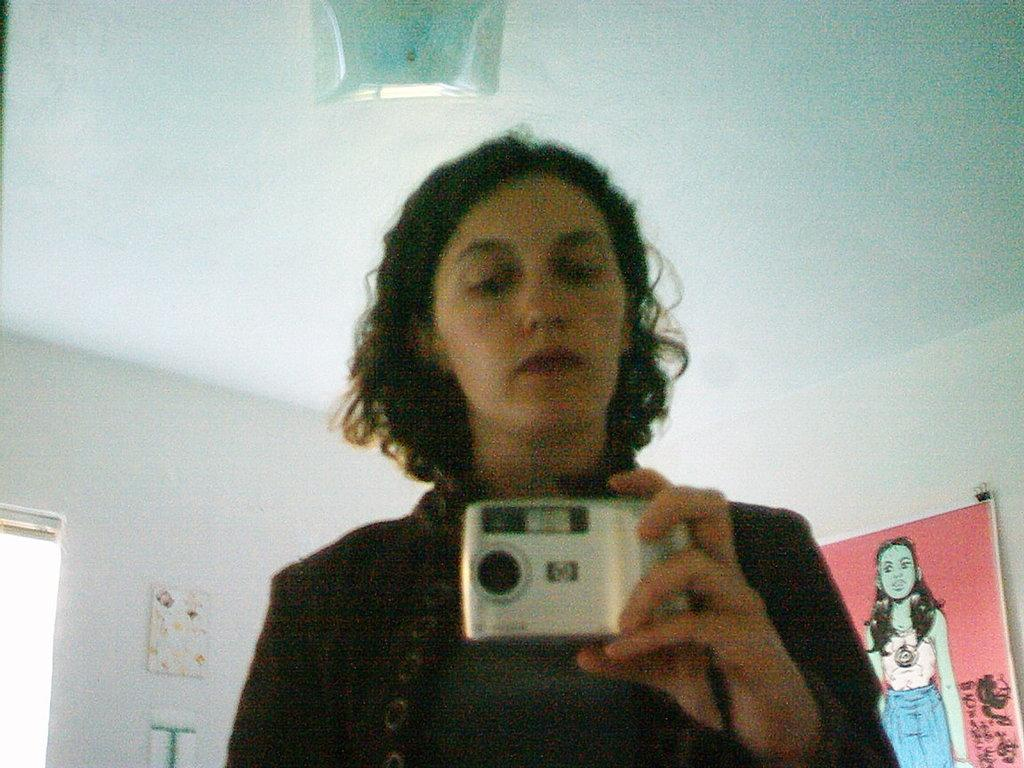What is the main subject of the image? There is a woman standing in the center of the image. What is the woman holding in the image? The woman is holding a camera. What can be seen in the background of the image? There is a window, a paper, a chart, and a wall in the image. How many clocks are visible in the image? There are no clocks visible in the image. What type of skin is visible on the woman's face in the image? There is no information about the woman's skin in the image. 